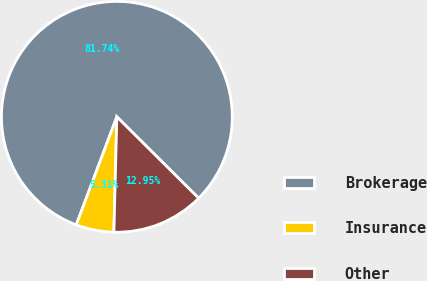<chart> <loc_0><loc_0><loc_500><loc_500><pie_chart><fcel>Brokerage<fcel>Insurance<fcel>Other<nl><fcel>81.75%<fcel>5.31%<fcel>12.95%<nl></chart> 